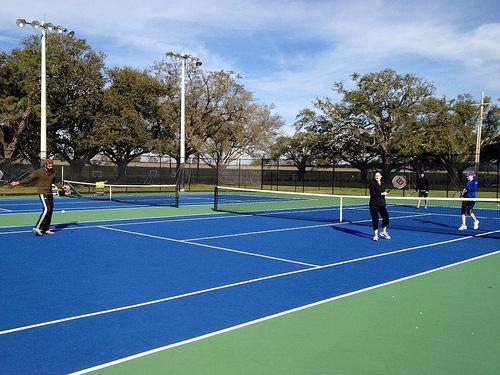How many people are wearing blue shirts?
Give a very brief answer. 1. 